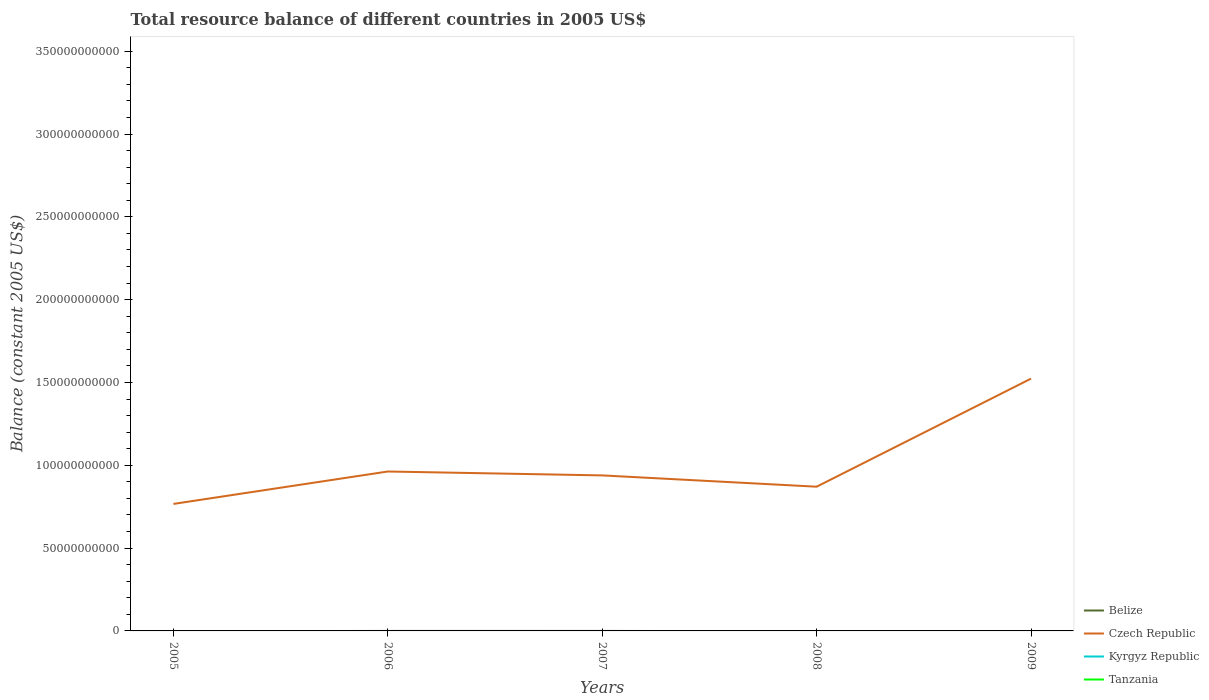How many different coloured lines are there?
Make the answer very short. 1. Does the line corresponding to Belize intersect with the line corresponding to Czech Republic?
Give a very brief answer. No. Is the number of lines equal to the number of legend labels?
Give a very brief answer. No. What is the total total resource balance in Czech Republic in the graph?
Make the answer very short. 2.36e+09. What is the difference between the highest and the second highest total resource balance in Czech Republic?
Ensure brevity in your answer.  7.57e+1. How many lines are there?
Provide a succinct answer. 1. How many years are there in the graph?
Make the answer very short. 5. What is the difference between two consecutive major ticks on the Y-axis?
Keep it short and to the point. 5.00e+1. Does the graph contain grids?
Provide a short and direct response. No. How are the legend labels stacked?
Ensure brevity in your answer.  Vertical. What is the title of the graph?
Make the answer very short. Total resource balance of different countries in 2005 US$. Does "United States" appear as one of the legend labels in the graph?
Provide a succinct answer. No. What is the label or title of the X-axis?
Your response must be concise. Years. What is the label or title of the Y-axis?
Offer a very short reply. Balance (constant 2005 US$). What is the Balance (constant 2005 US$) in Czech Republic in 2005?
Keep it short and to the point. 7.67e+1. What is the Balance (constant 2005 US$) of Tanzania in 2005?
Make the answer very short. 0. What is the Balance (constant 2005 US$) of Czech Republic in 2006?
Your response must be concise. 9.63e+1. What is the Balance (constant 2005 US$) of Kyrgyz Republic in 2006?
Offer a terse response. 0. What is the Balance (constant 2005 US$) in Tanzania in 2006?
Offer a very short reply. 0. What is the Balance (constant 2005 US$) in Belize in 2007?
Your answer should be compact. 0. What is the Balance (constant 2005 US$) of Czech Republic in 2007?
Your answer should be very brief. 9.39e+1. What is the Balance (constant 2005 US$) in Tanzania in 2007?
Your answer should be compact. 0. What is the Balance (constant 2005 US$) of Belize in 2008?
Give a very brief answer. 0. What is the Balance (constant 2005 US$) in Czech Republic in 2008?
Your answer should be very brief. 8.71e+1. What is the Balance (constant 2005 US$) in Kyrgyz Republic in 2008?
Offer a terse response. 0. What is the Balance (constant 2005 US$) in Belize in 2009?
Your answer should be compact. 0. What is the Balance (constant 2005 US$) in Czech Republic in 2009?
Offer a very short reply. 1.52e+11. What is the Balance (constant 2005 US$) in Tanzania in 2009?
Keep it short and to the point. 0. Across all years, what is the maximum Balance (constant 2005 US$) in Czech Republic?
Your answer should be compact. 1.52e+11. Across all years, what is the minimum Balance (constant 2005 US$) of Czech Republic?
Keep it short and to the point. 7.67e+1. What is the total Balance (constant 2005 US$) in Czech Republic in the graph?
Offer a terse response. 5.06e+11. What is the total Balance (constant 2005 US$) of Kyrgyz Republic in the graph?
Your answer should be compact. 0. What is the total Balance (constant 2005 US$) in Tanzania in the graph?
Make the answer very short. 0. What is the difference between the Balance (constant 2005 US$) in Czech Republic in 2005 and that in 2006?
Your response must be concise. -1.96e+1. What is the difference between the Balance (constant 2005 US$) of Czech Republic in 2005 and that in 2007?
Make the answer very short. -1.72e+1. What is the difference between the Balance (constant 2005 US$) of Czech Republic in 2005 and that in 2008?
Make the answer very short. -1.04e+1. What is the difference between the Balance (constant 2005 US$) in Czech Republic in 2005 and that in 2009?
Offer a very short reply. -7.57e+1. What is the difference between the Balance (constant 2005 US$) of Czech Republic in 2006 and that in 2007?
Make the answer very short. 2.36e+09. What is the difference between the Balance (constant 2005 US$) in Czech Republic in 2006 and that in 2008?
Make the answer very short. 9.18e+09. What is the difference between the Balance (constant 2005 US$) of Czech Republic in 2006 and that in 2009?
Provide a short and direct response. -5.61e+1. What is the difference between the Balance (constant 2005 US$) in Czech Republic in 2007 and that in 2008?
Ensure brevity in your answer.  6.81e+09. What is the difference between the Balance (constant 2005 US$) in Czech Republic in 2007 and that in 2009?
Provide a short and direct response. -5.84e+1. What is the difference between the Balance (constant 2005 US$) of Czech Republic in 2008 and that in 2009?
Your answer should be very brief. -6.53e+1. What is the average Balance (constant 2005 US$) of Belize per year?
Keep it short and to the point. 0. What is the average Balance (constant 2005 US$) in Czech Republic per year?
Offer a very short reply. 1.01e+11. What is the ratio of the Balance (constant 2005 US$) in Czech Republic in 2005 to that in 2006?
Your answer should be very brief. 0.8. What is the ratio of the Balance (constant 2005 US$) of Czech Republic in 2005 to that in 2007?
Offer a very short reply. 0.82. What is the ratio of the Balance (constant 2005 US$) in Czech Republic in 2005 to that in 2008?
Your answer should be compact. 0.88. What is the ratio of the Balance (constant 2005 US$) in Czech Republic in 2005 to that in 2009?
Provide a short and direct response. 0.5. What is the ratio of the Balance (constant 2005 US$) in Czech Republic in 2006 to that in 2007?
Your answer should be compact. 1.03. What is the ratio of the Balance (constant 2005 US$) of Czech Republic in 2006 to that in 2008?
Make the answer very short. 1.11. What is the ratio of the Balance (constant 2005 US$) in Czech Republic in 2006 to that in 2009?
Your answer should be very brief. 0.63. What is the ratio of the Balance (constant 2005 US$) of Czech Republic in 2007 to that in 2008?
Keep it short and to the point. 1.08. What is the ratio of the Balance (constant 2005 US$) in Czech Republic in 2007 to that in 2009?
Offer a terse response. 0.62. What is the ratio of the Balance (constant 2005 US$) in Czech Republic in 2008 to that in 2009?
Offer a very short reply. 0.57. What is the difference between the highest and the second highest Balance (constant 2005 US$) in Czech Republic?
Provide a short and direct response. 5.61e+1. What is the difference between the highest and the lowest Balance (constant 2005 US$) of Czech Republic?
Keep it short and to the point. 7.57e+1. 